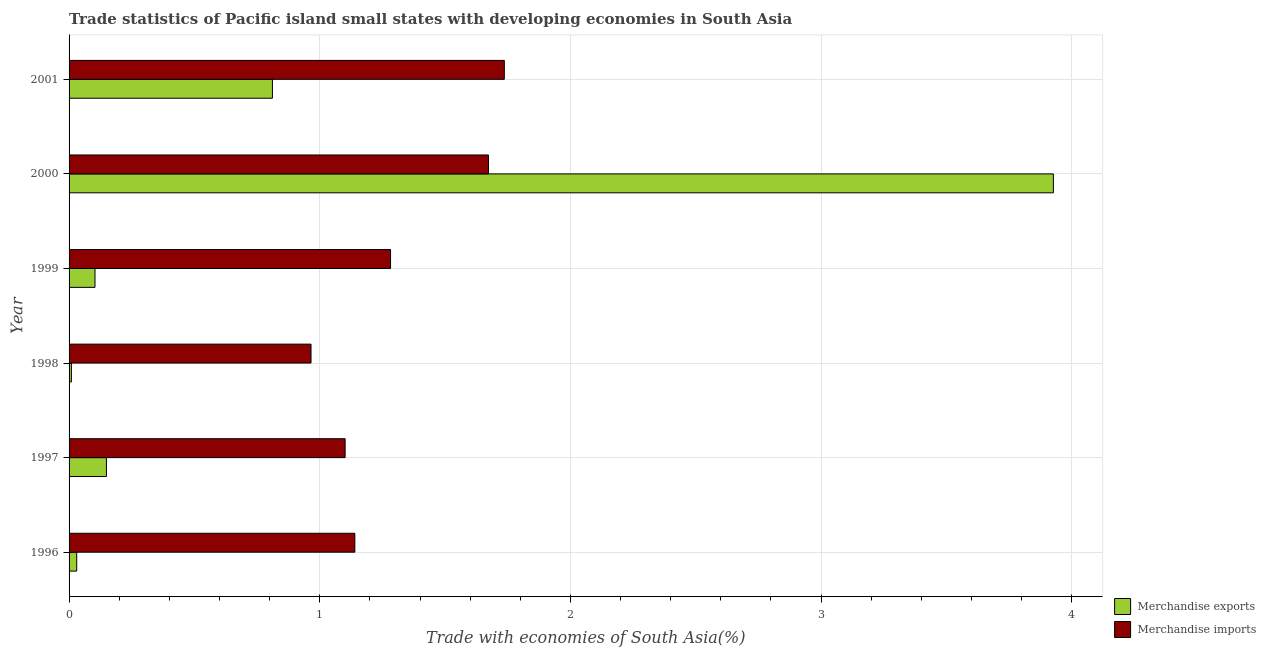How many different coloured bars are there?
Offer a very short reply. 2. Are the number of bars on each tick of the Y-axis equal?
Provide a succinct answer. Yes. How many bars are there on the 2nd tick from the top?
Ensure brevity in your answer.  2. What is the merchandise imports in 2001?
Keep it short and to the point. 1.74. Across all years, what is the maximum merchandise imports?
Your answer should be very brief. 1.74. Across all years, what is the minimum merchandise imports?
Provide a succinct answer. 0.97. In which year was the merchandise exports maximum?
Your answer should be compact. 2000. What is the total merchandise imports in the graph?
Offer a terse response. 7.9. What is the difference between the merchandise imports in 1997 and that in 1998?
Offer a terse response. 0.14. What is the difference between the merchandise exports in 1998 and the merchandise imports in 2000?
Provide a succinct answer. -1.66. What is the average merchandise imports per year?
Provide a short and direct response. 1.32. In the year 1996, what is the difference between the merchandise imports and merchandise exports?
Provide a short and direct response. 1.11. What is the ratio of the merchandise exports in 1999 to that in 2000?
Give a very brief answer. 0.03. Is the merchandise imports in 1996 less than that in 2000?
Give a very brief answer. Yes. What is the difference between the highest and the second highest merchandise exports?
Your answer should be very brief. 3.12. What is the difference between the highest and the lowest merchandise imports?
Make the answer very short. 0.77. In how many years, is the merchandise exports greater than the average merchandise exports taken over all years?
Provide a succinct answer. 1. Is the sum of the merchandise exports in 1996 and 1997 greater than the maximum merchandise imports across all years?
Your answer should be very brief. No. How many bars are there?
Your response must be concise. 12. Are the values on the major ticks of X-axis written in scientific E-notation?
Make the answer very short. No. Does the graph contain any zero values?
Your answer should be very brief. No. Does the graph contain grids?
Provide a succinct answer. Yes. Where does the legend appear in the graph?
Your response must be concise. Bottom right. What is the title of the graph?
Offer a very short reply. Trade statistics of Pacific island small states with developing economies in South Asia. What is the label or title of the X-axis?
Give a very brief answer. Trade with economies of South Asia(%). What is the Trade with economies of South Asia(%) in Merchandise exports in 1996?
Keep it short and to the point. 0.03. What is the Trade with economies of South Asia(%) in Merchandise imports in 1996?
Make the answer very short. 1.14. What is the Trade with economies of South Asia(%) in Merchandise exports in 1997?
Offer a very short reply. 0.15. What is the Trade with economies of South Asia(%) in Merchandise imports in 1997?
Your answer should be very brief. 1.1. What is the Trade with economies of South Asia(%) in Merchandise exports in 1998?
Provide a succinct answer. 0.01. What is the Trade with economies of South Asia(%) of Merchandise imports in 1998?
Provide a short and direct response. 0.97. What is the Trade with economies of South Asia(%) of Merchandise exports in 1999?
Make the answer very short. 0.1. What is the Trade with economies of South Asia(%) in Merchandise imports in 1999?
Provide a succinct answer. 1.28. What is the Trade with economies of South Asia(%) of Merchandise exports in 2000?
Provide a short and direct response. 3.93. What is the Trade with economies of South Asia(%) of Merchandise imports in 2000?
Provide a succinct answer. 1.67. What is the Trade with economies of South Asia(%) of Merchandise exports in 2001?
Your answer should be very brief. 0.81. What is the Trade with economies of South Asia(%) in Merchandise imports in 2001?
Your response must be concise. 1.74. Across all years, what is the maximum Trade with economies of South Asia(%) of Merchandise exports?
Your answer should be very brief. 3.93. Across all years, what is the maximum Trade with economies of South Asia(%) in Merchandise imports?
Make the answer very short. 1.74. Across all years, what is the minimum Trade with economies of South Asia(%) in Merchandise exports?
Your answer should be very brief. 0.01. Across all years, what is the minimum Trade with economies of South Asia(%) of Merchandise imports?
Keep it short and to the point. 0.97. What is the total Trade with economies of South Asia(%) of Merchandise exports in the graph?
Make the answer very short. 5.03. What is the total Trade with economies of South Asia(%) in Merchandise imports in the graph?
Make the answer very short. 7.9. What is the difference between the Trade with economies of South Asia(%) of Merchandise exports in 1996 and that in 1997?
Your response must be concise. -0.12. What is the difference between the Trade with economies of South Asia(%) in Merchandise imports in 1996 and that in 1997?
Make the answer very short. 0.04. What is the difference between the Trade with economies of South Asia(%) in Merchandise exports in 1996 and that in 1998?
Offer a very short reply. 0.02. What is the difference between the Trade with economies of South Asia(%) in Merchandise imports in 1996 and that in 1998?
Your response must be concise. 0.17. What is the difference between the Trade with economies of South Asia(%) of Merchandise exports in 1996 and that in 1999?
Your answer should be compact. -0.07. What is the difference between the Trade with economies of South Asia(%) in Merchandise imports in 1996 and that in 1999?
Provide a succinct answer. -0.14. What is the difference between the Trade with economies of South Asia(%) of Merchandise exports in 1996 and that in 2000?
Offer a very short reply. -3.9. What is the difference between the Trade with economies of South Asia(%) of Merchandise imports in 1996 and that in 2000?
Keep it short and to the point. -0.53. What is the difference between the Trade with economies of South Asia(%) in Merchandise exports in 1996 and that in 2001?
Give a very brief answer. -0.78. What is the difference between the Trade with economies of South Asia(%) of Merchandise imports in 1996 and that in 2001?
Offer a terse response. -0.6. What is the difference between the Trade with economies of South Asia(%) in Merchandise exports in 1997 and that in 1998?
Provide a short and direct response. 0.14. What is the difference between the Trade with economies of South Asia(%) of Merchandise imports in 1997 and that in 1998?
Ensure brevity in your answer.  0.14. What is the difference between the Trade with economies of South Asia(%) in Merchandise exports in 1997 and that in 1999?
Your answer should be compact. 0.05. What is the difference between the Trade with economies of South Asia(%) in Merchandise imports in 1997 and that in 1999?
Your response must be concise. -0.18. What is the difference between the Trade with economies of South Asia(%) of Merchandise exports in 1997 and that in 2000?
Keep it short and to the point. -3.78. What is the difference between the Trade with economies of South Asia(%) in Merchandise imports in 1997 and that in 2000?
Keep it short and to the point. -0.57. What is the difference between the Trade with economies of South Asia(%) in Merchandise exports in 1997 and that in 2001?
Provide a succinct answer. -0.66. What is the difference between the Trade with economies of South Asia(%) in Merchandise imports in 1997 and that in 2001?
Provide a short and direct response. -0.64. What is the difference between the Trade with economies of South Asia(%) of Merchandise exports in 1998 and that in 1999?
Your answer should be compact. -0.09. What is the difference between the Trade with economies of South Asia(%) in Merchandise imports in 1998 and that in 1999?
Your answer should be compact. -0.32. What is the difference between the Trade with economies of South Asia(%) of Merchandise exports in 1998 and that in 2000?
Your answer should be very brief. -3.92. What is the difference between the Trade with economies of South Asia(%) of Merchandise imports in 1998 and that in 2000?
Provide a succinct answer. -0.71. What is the difference between the Trade with economies of South Asia(%) of Merchandise exports in 1998 and that in 2001?
Your answer should be very brief. -0.8. What is the difference between the Trade with economies of South Asia(%) in Merchandise imports in 1998 and that in 2001?
Keep it short and to the point. -0.77. What is the difference between the Trade with economies of South Asia(%) in Merchandise exports in 1999 and that in 2000?
Keep it short and to the point. -3.82. What is the difference between the Trade with economies of South Asia(%) in Merchandise imports in 1999 and that in 2000?
Your answer should be very brief. -0.39. What is the difference between the Trade with economies of South Asia(%) in Merchandise exports in 1999 and that in 2001?
Provide a succinct answer. -0.71. What is the difference between the Trade with economies of South Asia(%) of Merchandise imports in 1999 and that in 2001?
Your answer should be compact. -0.45. What is the difference between the Trade with economies of South Asia(%) in Merchandise exports in 2000 and that in 2001?
Give a very brief answer. 3.12. What is the difference between the Trade with economies of South Asia(%) of Merchandise imports in 2000 and that in 2001?
Provide a succinct answer. -0.06. What is the difference between the Trade with economies of South Asia(%) of Merchandise exports in 1996 and the Trade with economies of South Asia(%) of Merchandise imports in 1997?
Provide a short and direct response. -1.07. What is the difference between the Trade with economies of South Asia(%) of Merchandise exports in 1996 and the Trade with economies of South Asia(%) of Merchandise imports in 1998?
Your answer should be compact. -0.93. What is the difference between the Trade with economies of South Asia(%) of Merchandise exports in 1996 and the Trade with economies of South Asia(%) of Merchandise imports in 1999?
Provide a short and direct response. -1.25. What is the difference between the Trade with economies of South Asia(%) of Merchandise exports in 1996 and the Trade with economies of South Asia(%) of Merchandise imports in 2000?
Make the answer very short. -1.64. What is the difference between the Trade with economies of South Asia(%) of Merchandise exports in 1996 and the Trade with economies of South Asia(%) of Merchandise imports in 2001?
Offer a very short reply. -1.71. What is the difference between the Trade with economies of South Asia(%) of Merchandise exports in 1997 and the Trade with economies of South Asia(%) of Merchandise imports in 1998?
Make the answer very short. -0.82. What is the difference between the Trade with economies of South Asia(%) of Merchandise exports in 1997 and the Trade with economies of South Asia(%) of Merchandise imports in 1999?
Your answer should be very brief. -1.13. What is the difference between the Trade with economies of South Asia(%) of Merchandise exports in 1997 and the Trade with economies of South Asia(%) of Merchandise imports in 2000?
Offer a very short reply. -1.52. What is the difference between the Trade with economies of South Asia(%) of Merchandise exports in 1997 and the Trade with economies of South Asia(%) of Merchandise imports in 2001?
Provide a succinct answer. -1.59. What is the difference between the Trade with economies of South Asia(%) in Merchandise exports in 1998 and the Trade with economies of South Asia(%) in Merchandise imports in 1999?
Make the answer very short. -1.27. What is the difference between the Trade with economies of South Asia(%) of Merchandise exports in 1998 and the Trade with economies of South Asia(%) of Merchandise imports in 2000?
Provide a short and direct response. -1.66. What is the difference between the Trade with economies of South Asia(%) of Merchandise exports in 1998 and the Trade with economies of South Asia(%) of Merchandise imports in 2001?
Your answer should be compact. -1.73. What is the difference between the Trade with economies of South Asia(%) of Merchandise exports in 1999 and the Trade with economies of South Asia(%) of Merchandise imports in 2000?
Your response must be concise. -1.57. What is the difference between the Trade with economies of South Asia(%) in Merchandise exports in 1999 and the Trade with economies of South Asia(%) in Merchandise imports in 2001?
Provide a short and direct response. -1.63. What is the difference between the Trade with economies of South Asia(%) of Merchandise exports in 2000 and the Trade with economies of South Asia(%) of Merchandise imports in 2001?
Offer a terse response. 2.19. What is the average Trade with economies of South Asia(%) in Merchandise exports per year?
Make the answer very short. 0.84. What is the average Trade with economies of South Asia(%) of Merchandise imports per year?
Your response must be concise. 1.32. In the year 1996, what is the difference between the Trade with economies of South Asia(%) of Merchandise exports and Trade with economies of South Asia(%) of Merchandise imports?
Ensure brevity in your answer.  -1.11. In the year 1997, what is the difference between the Trade with economies of South Asia(%) in Merchandise exports and Trade with economies of South Asia(%) in Merchandise imports?
Keep it short and to the point. -0.95. In the year 1998, what is the difference between the Trade with economies of South Asia(%) of Merchandise exports and Trade with economies of South Asia(%) of Merchandise imports?
Offer a very short reply. -0.96. In the year 1999, what is the difference between the Trade with economies of South Asia(%) in Merchandise exports and Trade with economies of South Asia(%) in Merchandise imports?
Offer a terse response. -1.18. In the year 2000, what is the difference between the Trade with economies of South Asia(%) in Merchandise exports and Trade with economies of South Asia(%) in Merchandise imports?
Ensure brevity in your answer.  2.25. In the year 2001, what is the difference between the Trade with economies of South Asia(%) of Merchandise exports and Trade with economies of South Asia(%) of Merchandise imports?
Keep it short and to the point. -0.93. What is the ratio of the Trade with economies of South Asia(%) in Merchandise exports in 1996 to that in 1997?
Give a very brief answer. 0.2. What is the ratio of the Trade with economies of South Asia(%) of Merchandise imports in 1996 to that in 1997?
Give a very brief answer. 1.04. What is the ratio of the Trade with economies of South Asia(%) of Merchandise exports in 1996 to that in 1998?
Your response must be concise. 3.27. What is the ratio of the Trade with economies of South Asia(%) of Merchandise imports in 1996 to that in 1998?
Your answer should be very brief. 1.18. What is the ratio of the Trade with economies of South Asia(%) in Merchandise exports in 1996 to that in 1999?
Your answer should be compact. 0.29. What is the ratio of the Trade with economies of South Asia(%) of Merchandise imports in 1996 to that in 1999?
Give a very brief answer. 0.89. What is the ratio of the Trade with economies of South Asia(%) of Merchandise exports in 1996 to that in 2000?
Make the answer very short. 0.01. What is the ratio of the Trade with economies of South Asia(%) in Merchandise imports in 1996 to that in 2000?
Ensure brevity in your answer.  0.68. What is the ratio of the Trade with economies of South Asia(%) of Merchandise exports in 1996 to that in 2001?
Your response must be concise. 0.04. What is the ratio of the Trade with economies of South Asia(%) in Merchandise imports in 1996 to that in 2001?
Offer a very short reply. 0.66. What is the ratio of the Trade with economies of South Asia(%) in Merchandise exports in 1997 to that in 1998?
Your answer should be very brief. 15.97. What is the ratio of the Trade with economies of South Asia(%) of Merchandise imports in 1997 to that in 1998?
Your answer should be compact. 1.14. What is the ratio of the Trade with economies of South Asia(%) of Merchandise exports in 1997 to that in 1999?
Offer a very short reply. 1.44. What is the ratio of the Trade with economies of South Asia(%) in Merchandise imports in 1997 to that in 1999?
Make the answer very short. 0.86. What is the ratio of the Trade with economies of South Asia(%) of Merchandise exports in 1997 to that in 2000?
Make the answer very short. 0.04. What is the ratio of the Trade with economies of South Asia(%) in Merchandise imports in 1997 to that in 2000?
Provide a short and direct response. 0.66. What is the ratio of the Trade with economies of South Asia(%) of Merchandise exports in 1997 to that in 2001?
Keep it short and to the point. 0.18. What is the ratio of the Trade with economies of South Asia(%) of Merchandise imports in 1997 to that in 2001?
Provide a succinct answer. 0.63. What is the ratio of the Trade with economies of South Asia(%) in Merchandise exports in 1998 to that in 1999?
Your response must be concise. 0.09. What is the ratio of the Trade with economies of South Asia(%) in Merchandise imports in 1998 to that in 1999?
Make the answer very short. 0.75. What is the ratio of the Trade with economies of South Asia(%) in Merchandise exports in 1998 to that in 2000?
Your response must be concise. 0. What is the ratio of the Trade with economies of South Asia(%) in Merchandise imports in 1998 to that in 2000?
Your answer should be very brief. 0.58. What is the ratio of the Trade with economies of South Asia(%) of Merchandise exports in 1998 to that in 2001?
Your answer should be very brief. 0.01. What is the ratio of the Trade with economies of South Asia(%) in Merchandise imports in 1998 to that in 2001?
Your response must be concise. 0.56. What is the ratio of the Trade with economies of South Asia(%) in Merchandise exports in 1999 to that in 2000?
Provide a short and direct response. 0.03. What is the ratio of the Trade with economies of South Asia(%) of Merchandise imports in 1999 to that in 2000?
Your answer should be very brief. 0.77. What is the ratio of the Trade with economies of South Asia(%) of Merchandise exports in 1999 to that in 2001?
Give a very brief answer. 0.13. What is the ratio of the Trade with economies of South Asia(%) of Merchandise imports in 1999 to that in 2001?
Make the answer very short. 0.74. What is the ratio of the Trade with economies of South Asia(%) in Merchandise exports in 2000 to that in 2001?
Give a very brief answer. 4.84. What is the ratio of the Trade with economies of South Asia(%) in Merchandise imports in 2000 to that in 2001?
Give a very brief answer. 0.96. What is the difference between the highest and the second highest Trade with economies of South Asia(%) of Merchandise exports?
Provide a short and direct response. 3.12. What is the difference between the highest and the second highest Trade with economies of South Asia(%) of Merchandise imports?
Ensure brevity in your answer.  0.06. What is the difference between the highest and the lowest Trade with economies of South Asia(%) of Merchandise exports?
Your response must be concise. 3.92. What is the difference between the highest and the lowest Trade with economies of South Asia(%) of Merchandise imports?
Offer a very short reply. 0.77. 